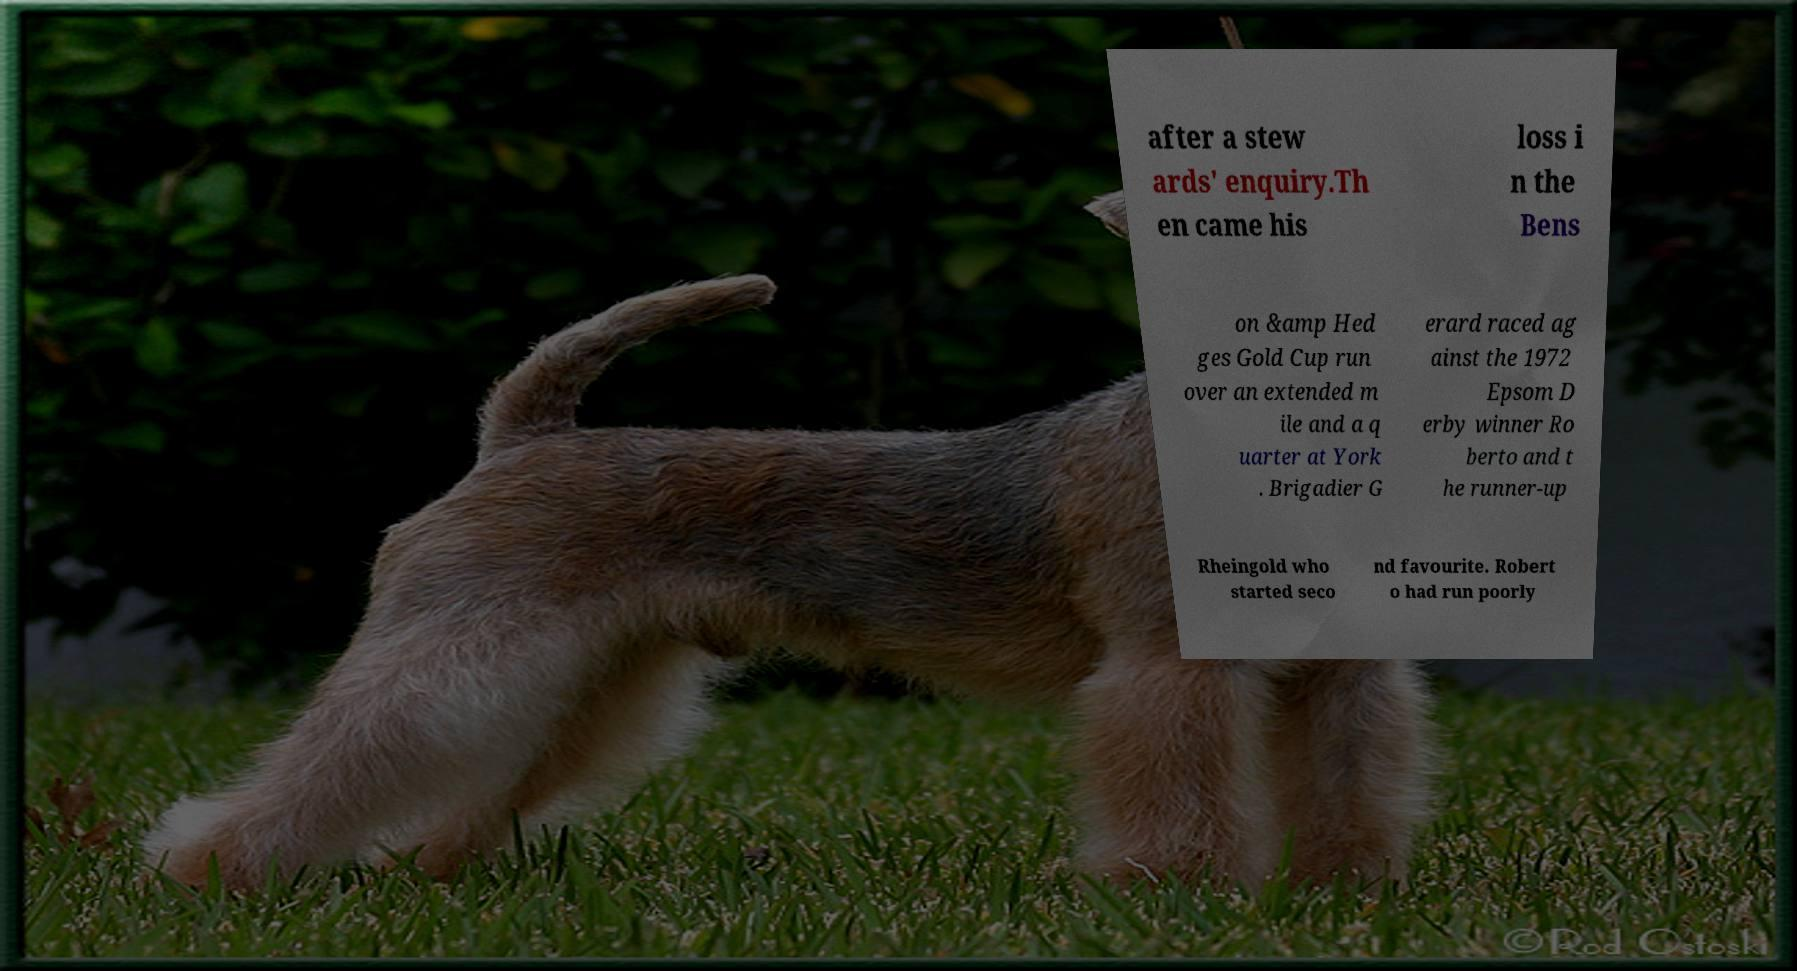I need the written content from this picture converted into text. Can you do that? after a stew ards' enquiry.Th en came his loss i n the Bens on &amp Hed ges Gold Cup run over an extended m ile and a q uarter at York . Brigadier G erard raced ag ainst the 1972 Epsom D erby winner Ro berto and t he runner-up Rheingold who started seco nd favourite. Robert o had run poorly 